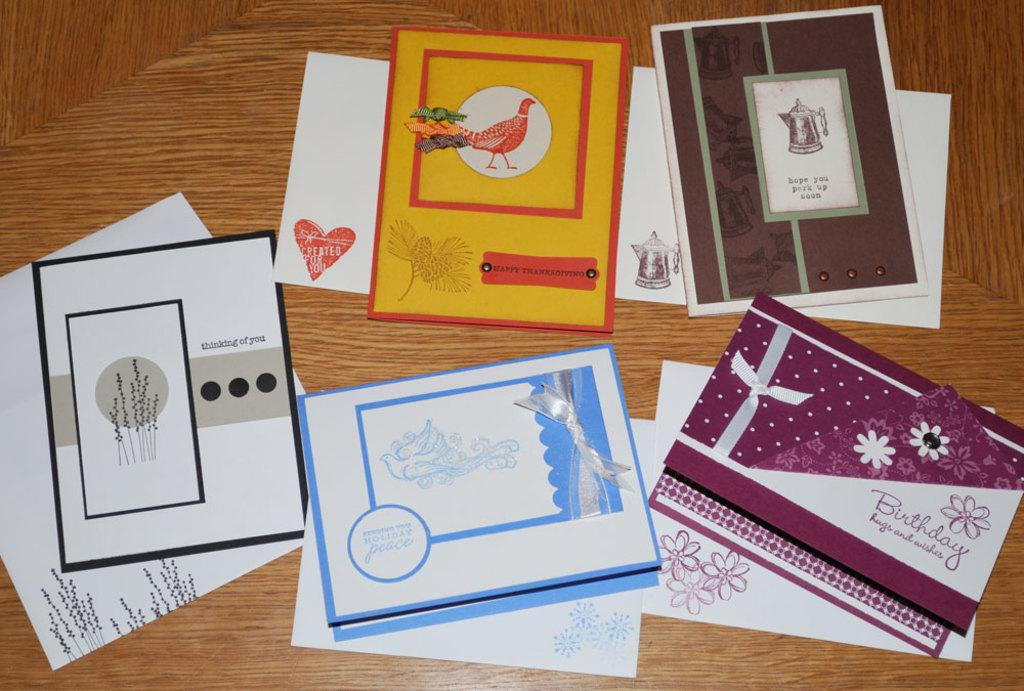<image>
Summarize the visual content of the image. The Birthday card, get well (hope you perk up real soon), Christmas card (sending you holiday peace),  Happy Thanksgiving card,and a 